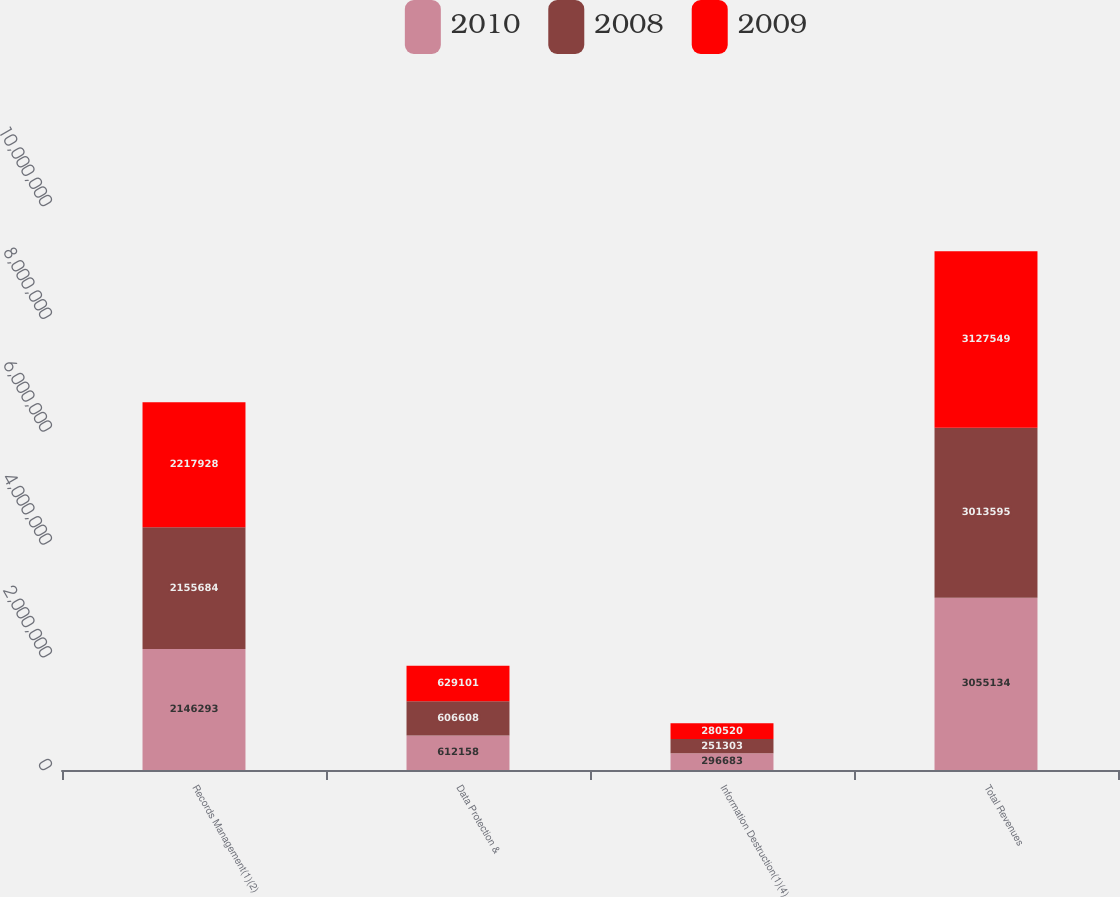Convert chart to OTSL. <chart><loc_0><loc_0><loc_500><loc_500><stacked_bar_chart><ecel><fcel>Records Management(1)(2)<fcel>Data Protection &<fcel>Information Destruction(1)(4)<fcel>Total Revenues<nl><fcel>2010<fcel>2.14629e+06<fcel>612158<fcel>296683<fcel>3.05513e+06<nl><fcel>2008<fcel>2.15568e+06<fcel>606608<fcel>251303<fcel>3.0136e+06<nl><fcel>2009<fcel>2.21793e+06<fcel>629101<fcel>280520<fcel>3.12755e+06<nl></chart> 